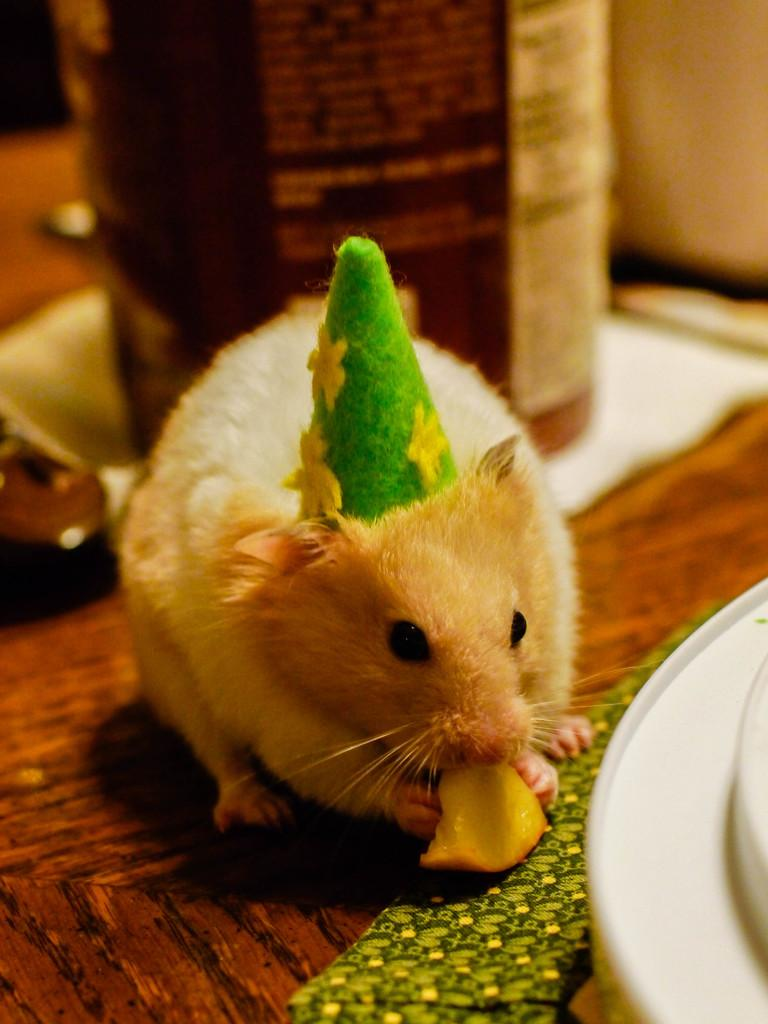What animal is present in the image? There is a mouse in the image. What is the mouse doing in the image? The mouse is eating fruit in the image. Can you describe any accessories the mouse is wearing? Yes, there is a cap on the mouse. What type of tableware can be seen in the image? There are plates on the table. What else is present on the table besides plates? There is a bottle and other unspecified items on the table. How does the mouse show respect to the zipper in the image? There is no zipper present in the image, so the mouse cannot show respect to it. 